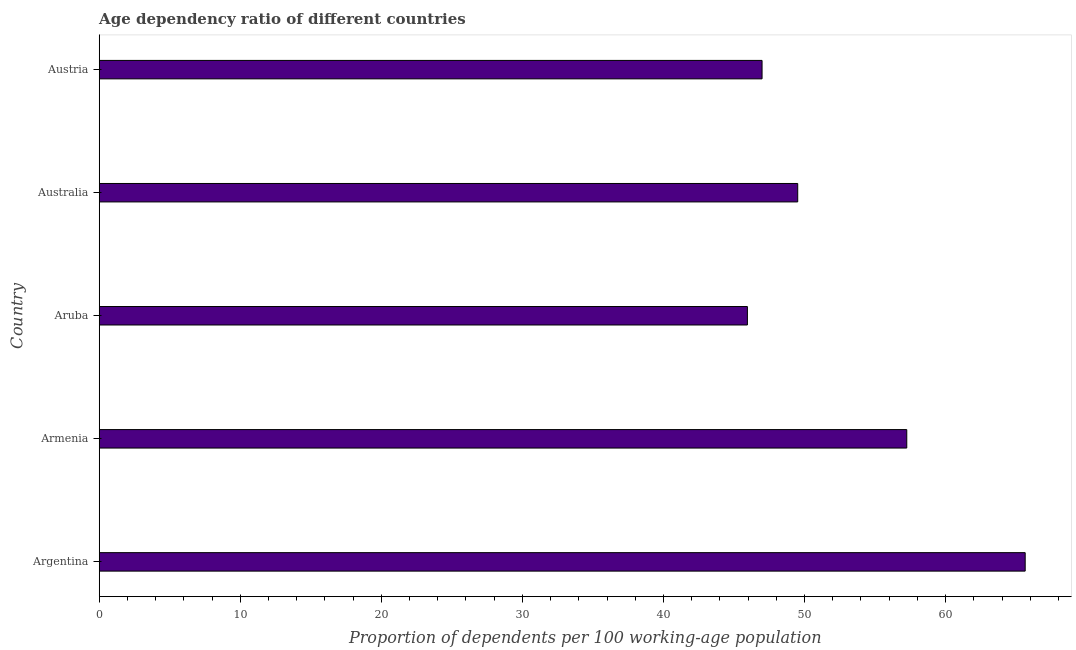Does the graph contain any zero values?
Your response must be concise. No. What is the title of the graph?
Your answer should be very brief. Age dependency ratio of different countries. What is the label or title of the X-axis?
Your answer should be very brief. Proportion of dependents per 100 working-age population. What is the label or title of the Y-axis?
Provide a short and direct response. Country. What is the age dependency ratio in Austria?
Your response must be concise. 46.99. Across all countries, what is the maximum age dependency ratio?
Your answer should be very brief. 65.64. Across all countries, what is the minimum age dependency ratio?
Make the answer very short. 45.95. In which country was the age dependency ratio maximum?
Make the answer very short. Argentina. In which country was the age dependency ratio minimum?
Offer a terse response. Aruba. What is the sum of the age dependency ratio?
Provide a succinct answer. 265.35. What is the difference between the age dependency ratio in Armenia and Australia?
Offer a very short reply. 7.73. What is the average age dependency ratio per country?
Your answer should be compact. 53.07. What is the median age dependency ratio?
Give a very brief answer. 49.52. In how many countries, is the age dependency ratio greater than 66 ?
Give a very brief answer. 0. What is the ratio of the age dependency ratio in Argentina to that in Aruba?
Keep it short and to the point. 1.43. Is the age dependency ratio in Armenia less than that in Austria?
Provide a succinct answer. No. What is the difference between the highest and the second highest age dependency ratio?
Provide a short and direct response. 8.4. What is the difference between the highest and the lowest age dependency ratio?
Keep it short and to the point. 19.69. In how many countries, is the age dependency ratio greater than the average age dependency ratio taken over all countries?
Offer a very short reply. 2. How many bars are there?
Your answer should be compact. 5. What is the difference between two consecutive major ticks on the X-axis?
Your answer should be very brief. 10. What is the Proportion of dependents per 100 working-age population in Argentina?
Your answer should be very brief. 65.64. What is the Proportion of dependents per 100 working-age population in Armenia?
Give a very brief answer. 57.25. What is the Proportion of dependents per 100 working-age population of Aruba?
Keep it short and to the point. 45.95. What is the Proportion of dependents per 100 working-age population in Australia?
Keep it short and to the point. 49.52. What is the Proportion of dependents per 100 working-age population of Austria?
Make the answer very short. 46.99. What is the difference between the Proportion of dependents per 100 working-age population in Argentina and Armenia?
Provide a short and direct response. 8.4. What is the difference between the Proportion of dependents per 100 working-age population in Argentina and Aruba?
Offer a terse response. 19.69. What is the difference between the Proportion of dependents per 100 working-age population in Argentina and Australia?
Provide a succinct answer. 16.13. What is the difference between the Proportion of dependents per 100 working-age population in Argentina and Austria?
Keep it short and to the point. 18.65. What is the difference between the Proportion of dependents per 100 working-age population in Armenia and Aruba?
Ensure brevity in your answer.  11.3. What is the difference between the Proportion of dependents per 100 working-age population in Armenia and Australia?
Offer a terse response. 7.73. What is the difference between the Proportion of dependents per 100 working-age population in Armenia and Austria?
Give a very brief answer. 10.26. What is the difference between the Proportion of dependents per 100 working-age population in Aruba and Australia?
Ensure brevity in your answer.  -3.57. What is the difference between the Proportion of dependents per 100 working-age population in Aruba and Austria?
Provide a short and direct response. -1.04. What is the difference between the Proportion of dependents per 100 working-age population in Australia and Austria?
Your answer should be compact. 2.53. What is the ratio of the Proportion of dependents per 100 working-age population in Argentina to that in Armenia?
Offer a very short reply. 1.15. What is the ratio of the Proportion of dependents per 100 working-age population in Argentina to that in Aruba?
Provide a short and direct response. 1.43. What is the ratio of the Proportion of dependents per 100 working-age population in Argentina to that in Australia?
Your answer should be compact. 1.33. What is the ratio of the Proportion of dependents per 100 working-age population in Argentina to that in Austria?
Provide a short and direct response. 1.4. What is the ratio of the Proportion of dependents per 100 working-age population in Armenia to that in Aruba?
Your response must be concise. 1.25. What is the ratio of the Proportion of dependents per 100 working-age population in Armenia to that in Australia?
Provide a succinct answer. 1.16. What is the ratio of the Proportion of dependents per 100 working-age population in Armenia to that in Austria?
Your response must be concise. 1.22. What is the ratio of the Proportion of dependents per 100 working-age population in Aruba to that in Australia?
Offer a terse response. 0.93. What is the ratio of the Proportion of dependents per 100 working-age population in Australia to that in Austria?
Provide a succinct answer. 1.05. 